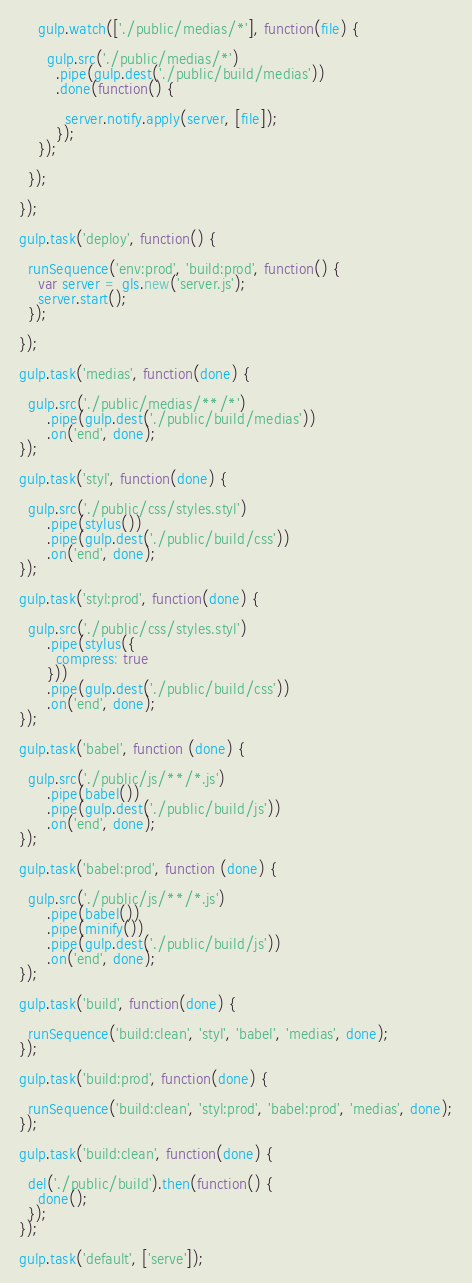Convert code to text. <code><loc_0><loc_0><loc_500><loc_500><_JavaScript_>
    gulp.watch(['./public/medias/*'], function(file) {

      gulp.src('./public/medias/*')
        .pipe(gulp.dest('./public/build/medias'))
        .done(function() {

          server.notify.apply(server, [file]);
        });
    });

  });

});

gulp.task('deploy', function() {

  runSequence('env:prod', 'build:prod', function() {
    var server = gls.new('server.js');
    server.start();
  });

});

gulp.task('medias', function(done) {

  gulp.src('./public/medias/**/*')
      .pipe(gulp.dest('./public/build/medias'))
      .on('end', done);
});

gulp.task('styl', function(done) {

  gulp.src('./public/css/styles.styl')
      .pipe(stylus())
      .pipe(gulp.dest('./public/build/css'))
      .on('end', done);
});

gulp.task('styl:prod', function(done) {

  gulp.src('./public/css/styles.styl')
      .pipe(stylus({
        compress: true
      }))
      .pipe(gulp.dest('./public/build/css'))
      .on('end', done);
});

gulp.task('babel', function (done) {

  gulp.src('./public/js/**/*.js')
      .pipe(babel())
      .pipe(gulp.dest('./public/build/js'))
      .on('end', done);
});

gulp.task('babel:prod', function (done) {

  gulp.src('./public/js/**/*.js')
      .pipe(babel())
      .pipe(minify())
      .pipe(gulp.dest('./public/build/js'))
      .on('end', done);
});

gulp.task('build', function(done) {

  runSequence('build:clean', 'styl', 'babel', 'medias', done);
});

gulp.task('build:prod', function(done) {

  runSequence('build:clean', 'styl:prod', 'babel:prod', 'medias', done);
});

gulp.task('build:clean', function(done) {

  del('./public/build').then(function() {
    done();
  });
});

gulp.task('default', ['serve']);
</code> 